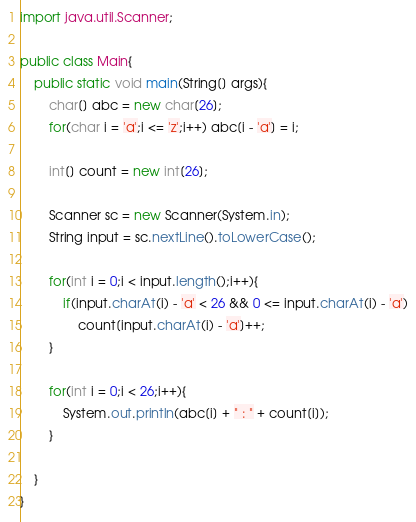<code> <loc_0><loc_0><loc_500><loc_500><_Java_>import java.util.Scanner;

public class Main{
	public static void main(String[] args){
		char[] abc = new char[26];
		for(char i = 'a';i <= 'z';i++) abc[i - 'a'] = i;

		int[] count = new int[26];

		Scanner sc = new Scanner(System.in);
		String input = sc.nextLine().toLowerCase();

		for(int i = 0;i < input.length();i++){
			if(input.charAt(i) - 'a' < 26 && 0 <= input.charAt(i) - 'a')
				count[input.charAt(i) - 'a']++;
		}

		for(int i = 0;i < 26;i++){
			System.out.println(abc[i] + " : " + count[i]);
		}

	}
}
</code> 